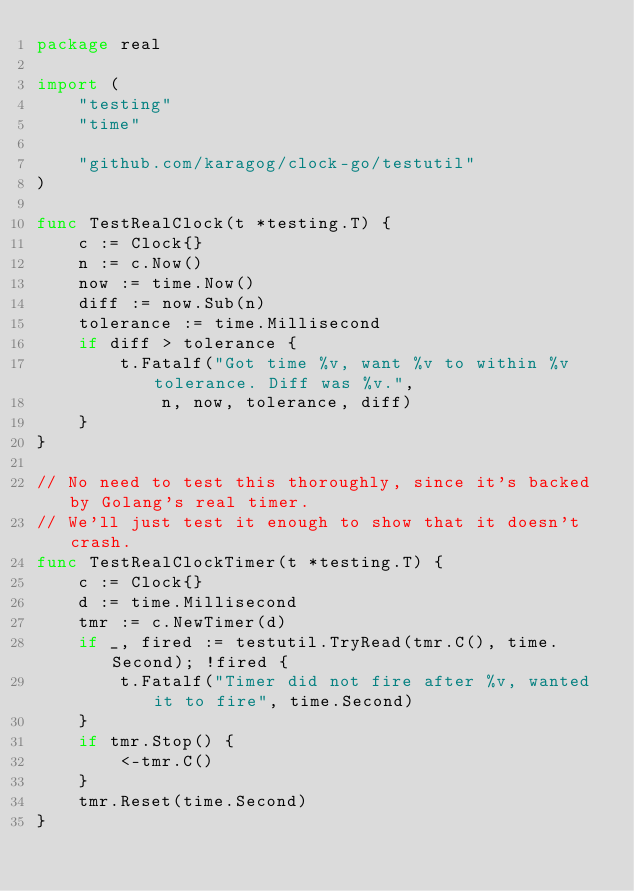<code> <loc_0><loc_0><loc_500><loc_500><_Go_>package real

import (
	"testing"
	"time"

	"github.com/karagog/clock-go/testutil"
)

func TestRealClock(t *testing.T) {
	c := Clock{}
	n := c.Now()
	now := time.Now()
	diff := now.Sub(n)
	tolerance := time.Millisecond
	if diff > tolerance {
		t.Fatalf("Got time %v, want %v to within %v tolerance. Diff was %v.",
			n, now, tolerance, diff)
	}
}

// No need to test this thoroughly, since it's backed by Golang's real timer.
// We'll just test it enough to show that it doesn't crash.
func TestRealClockTimer(t *testing.T) {
	c := Clock{}
	d := time.Millisecond
	tmr := c.NewTimer(d)
	if _, fired := testutil.TryRead(tmr.C(), time.Second); !fired {
		t.Fatalf("Timer did not fire after %v, wanted it to fire", time.Second)
	}
	if tmr.Stop() {
		<-tmr.C()
	}
	tmr.Reset(time.Second)
}
</code> 